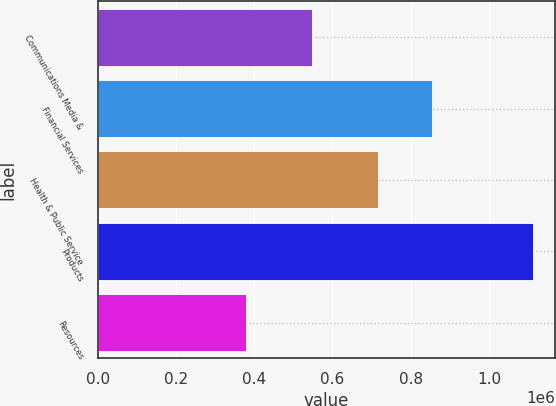Convert chart. <chart><loc_0><loc_0><loc_500><loc_500><bar_chart><fcel>Communications Media &<fcel>Financial Services<fcel>Health & Public Service<fcel>Products<fcel>Resources<nl><fcel>546566<fcel>854376<fcel>715849<fcel>1.11299e+06<fcel>379655<nl></chart> 